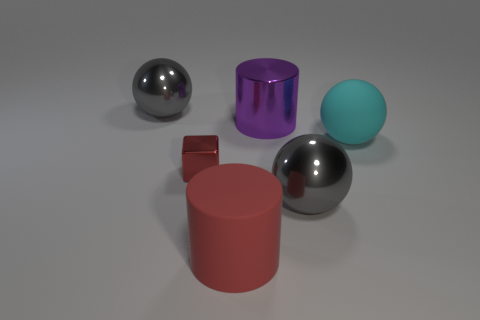Add 2 big shiny cylinders. How many objects exist? 8 Subtract all blocks. How many objects are left? 5 Subtract 0 yellow blocks. How many objects are left? 6 Subtract all big red things. Subtract all red metallic things. How many objects are left? 4 Add 1 large metal spheres. How many large metal spheres are left? 3 Add 1 large yellow metallic spheres. How many large yellow metallic spheres exist? 1 